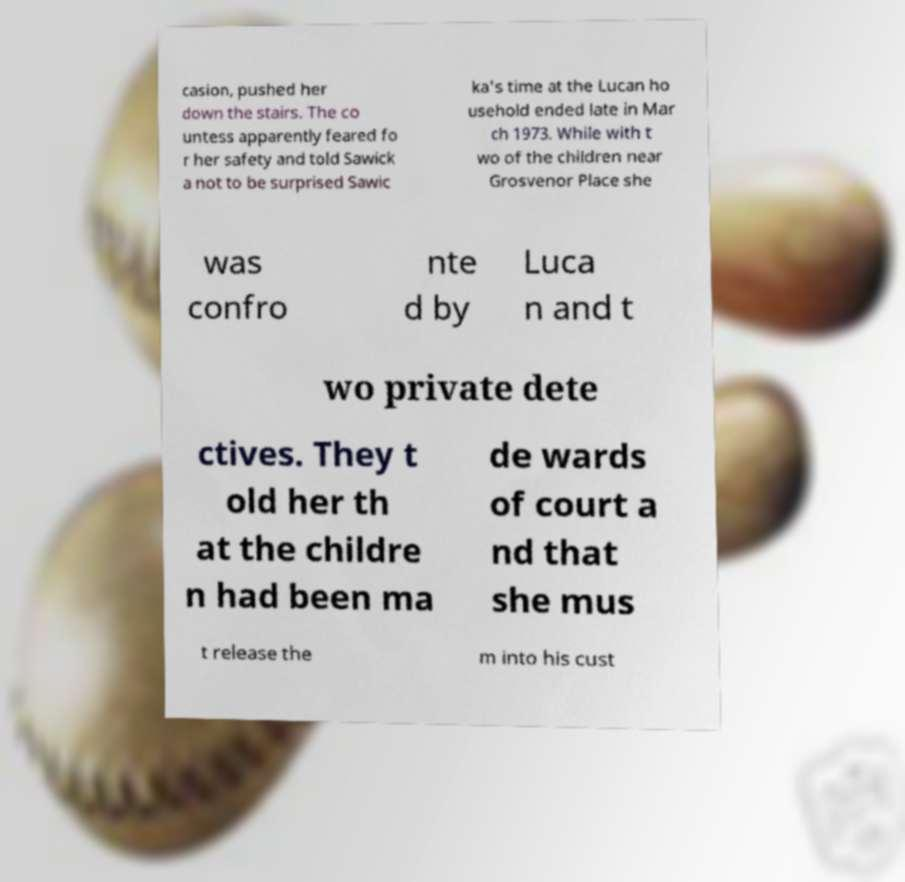For documentation purposes, I need the text within this image transcribed. Could you provide that? casion, pushed her down the stairs. The co untess apparently feared fo r her safety and told Sawick a not to be surprised Sawic ka's time at the Lucan ho usehold ended late in Mar ch 1973. While with t wo of the children near Grosvenor Place she was confro nte d by Luca n and t wo private dete ctives. They t old her th at the childre n had been ma de wards of court a nd that she mus t release the m into his cust 